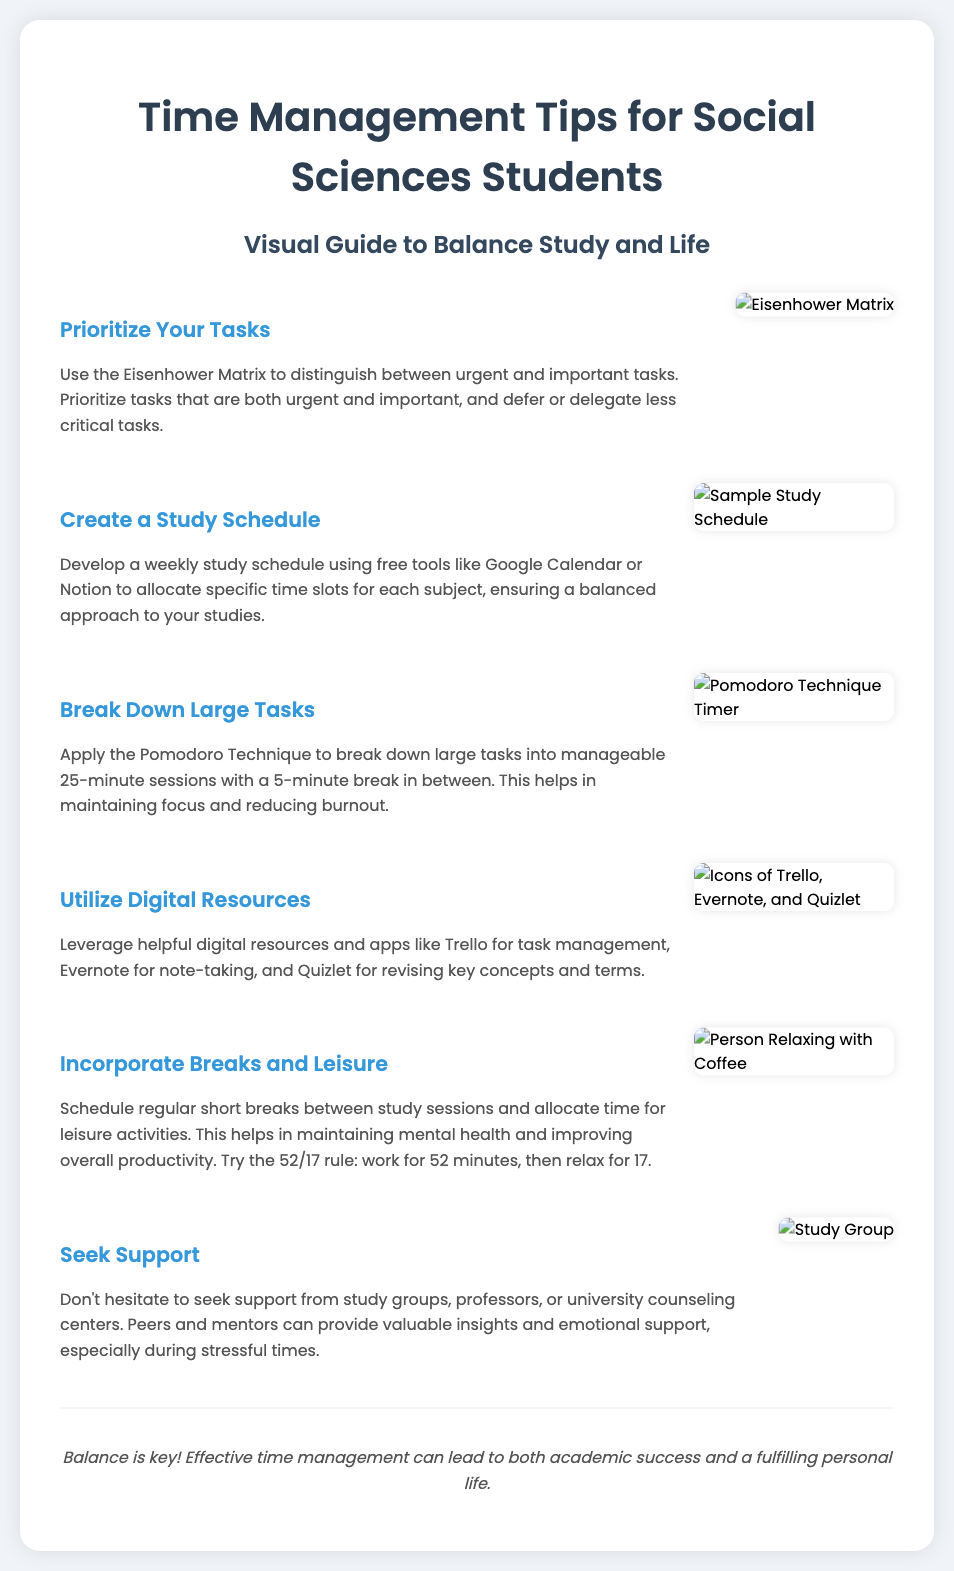What is the first tip for time management? The first tip is to prioritize tasks, specifically using the Eisenhower Matrix.
Answer: Prioritize Your Tasks What technique is suggested for breaking down large tasks? The Pomodoro Technique is recommended for breaking down large tasks.
Answer: Pomodoro Technique How long are the study sessions suggested in the Pomodoro Technique? Each session is suggested to be 25 minutes long with a break in between.
Answer: 25 minutes What is one digital resource mentioned for task management? Trello is one of the digital resources suggested for task management.
Answer: Trello What is the suggested work to relaxation ratio according to the 52/17 rule? The 52/17 rule suggests working for 52 minutes and then relaxing for 17 minutes.
Answer: 52/17 rule Who can provide valuable support during stressful times? Study groups, professors, or university counseling centers can provide valuable support.
Answer: Study groups What color is used for the headings in the poster? The headings use the color #3498db.
Answer: #3498db What visual aid is used in the tip about scheduling? A sample study schedule image is used as a visual aid.
Answer: Sample Study Schedule 